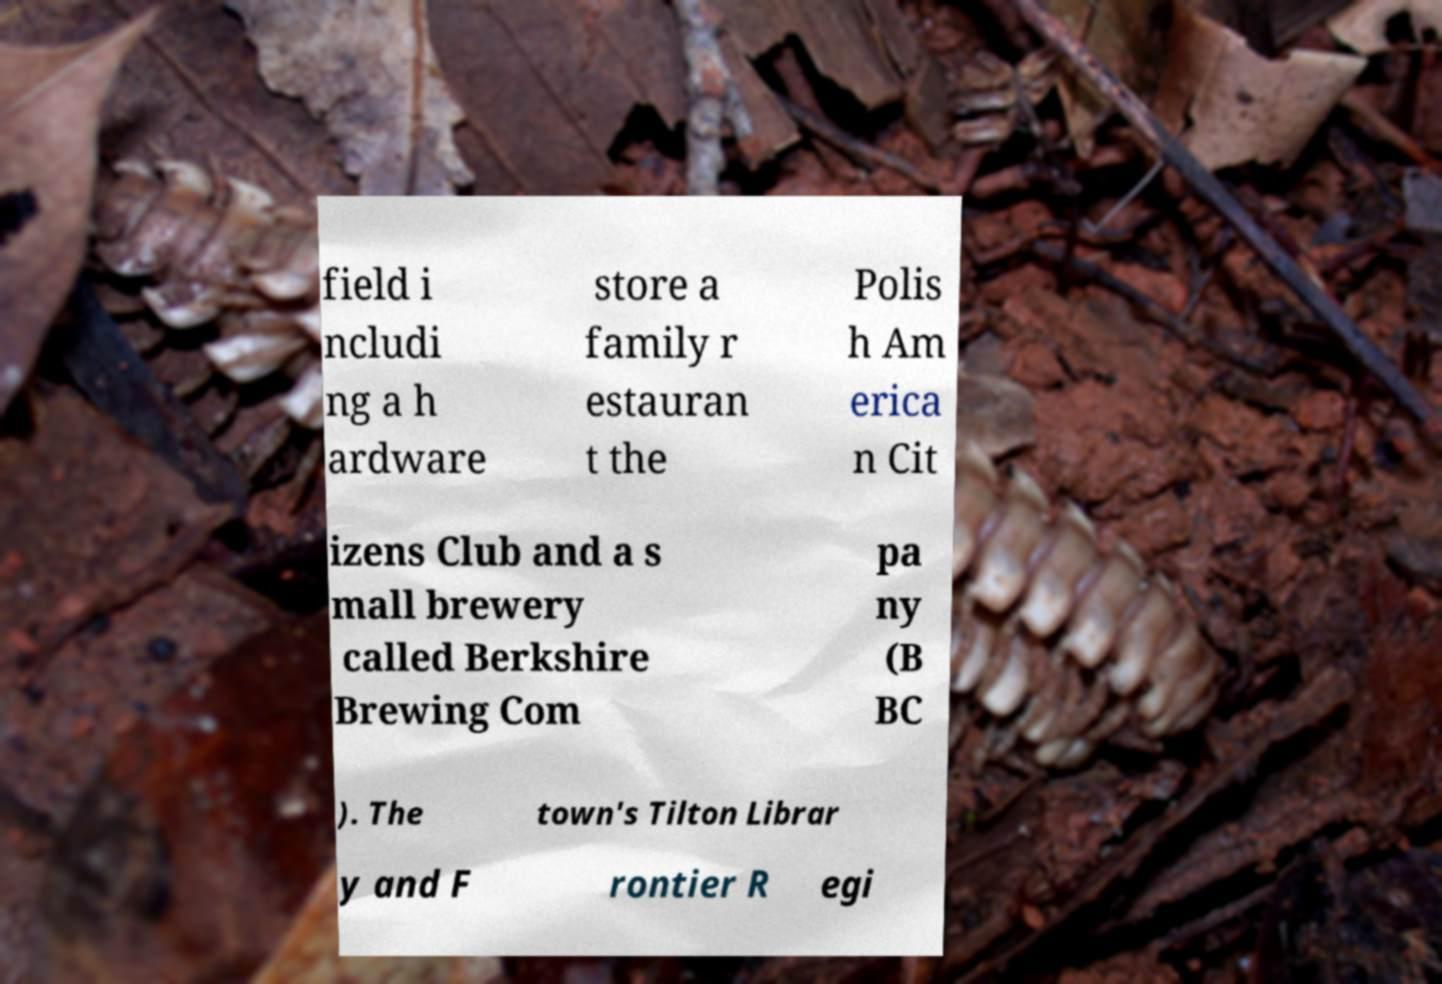Could you extract and type out the text from this image? field i ncludi ng a h ardware store a family r estauran t the Polis h Am erica n Cit izens Club and a s mall brewery called Berkshire Brewing Com pa ny (B BC ). The town's Tilton Librar y and F rontier R egi 